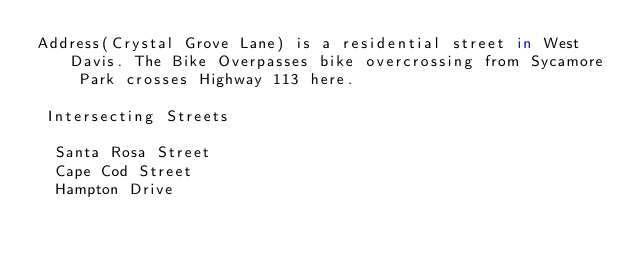Convert code to text. <code><loc_0><loc_0><loc_500><loc_500><_FORTRAN_>Address(Crystal Grove Lane) is a residential street in West Davis. The Bike Overpasses bike overcrossing from Sycamore Park crosses Highway 113 here.

 Intersecting Streets 

  Santa Rosa Street
  Cape Cod Street
  Hampton Drive

</code> 